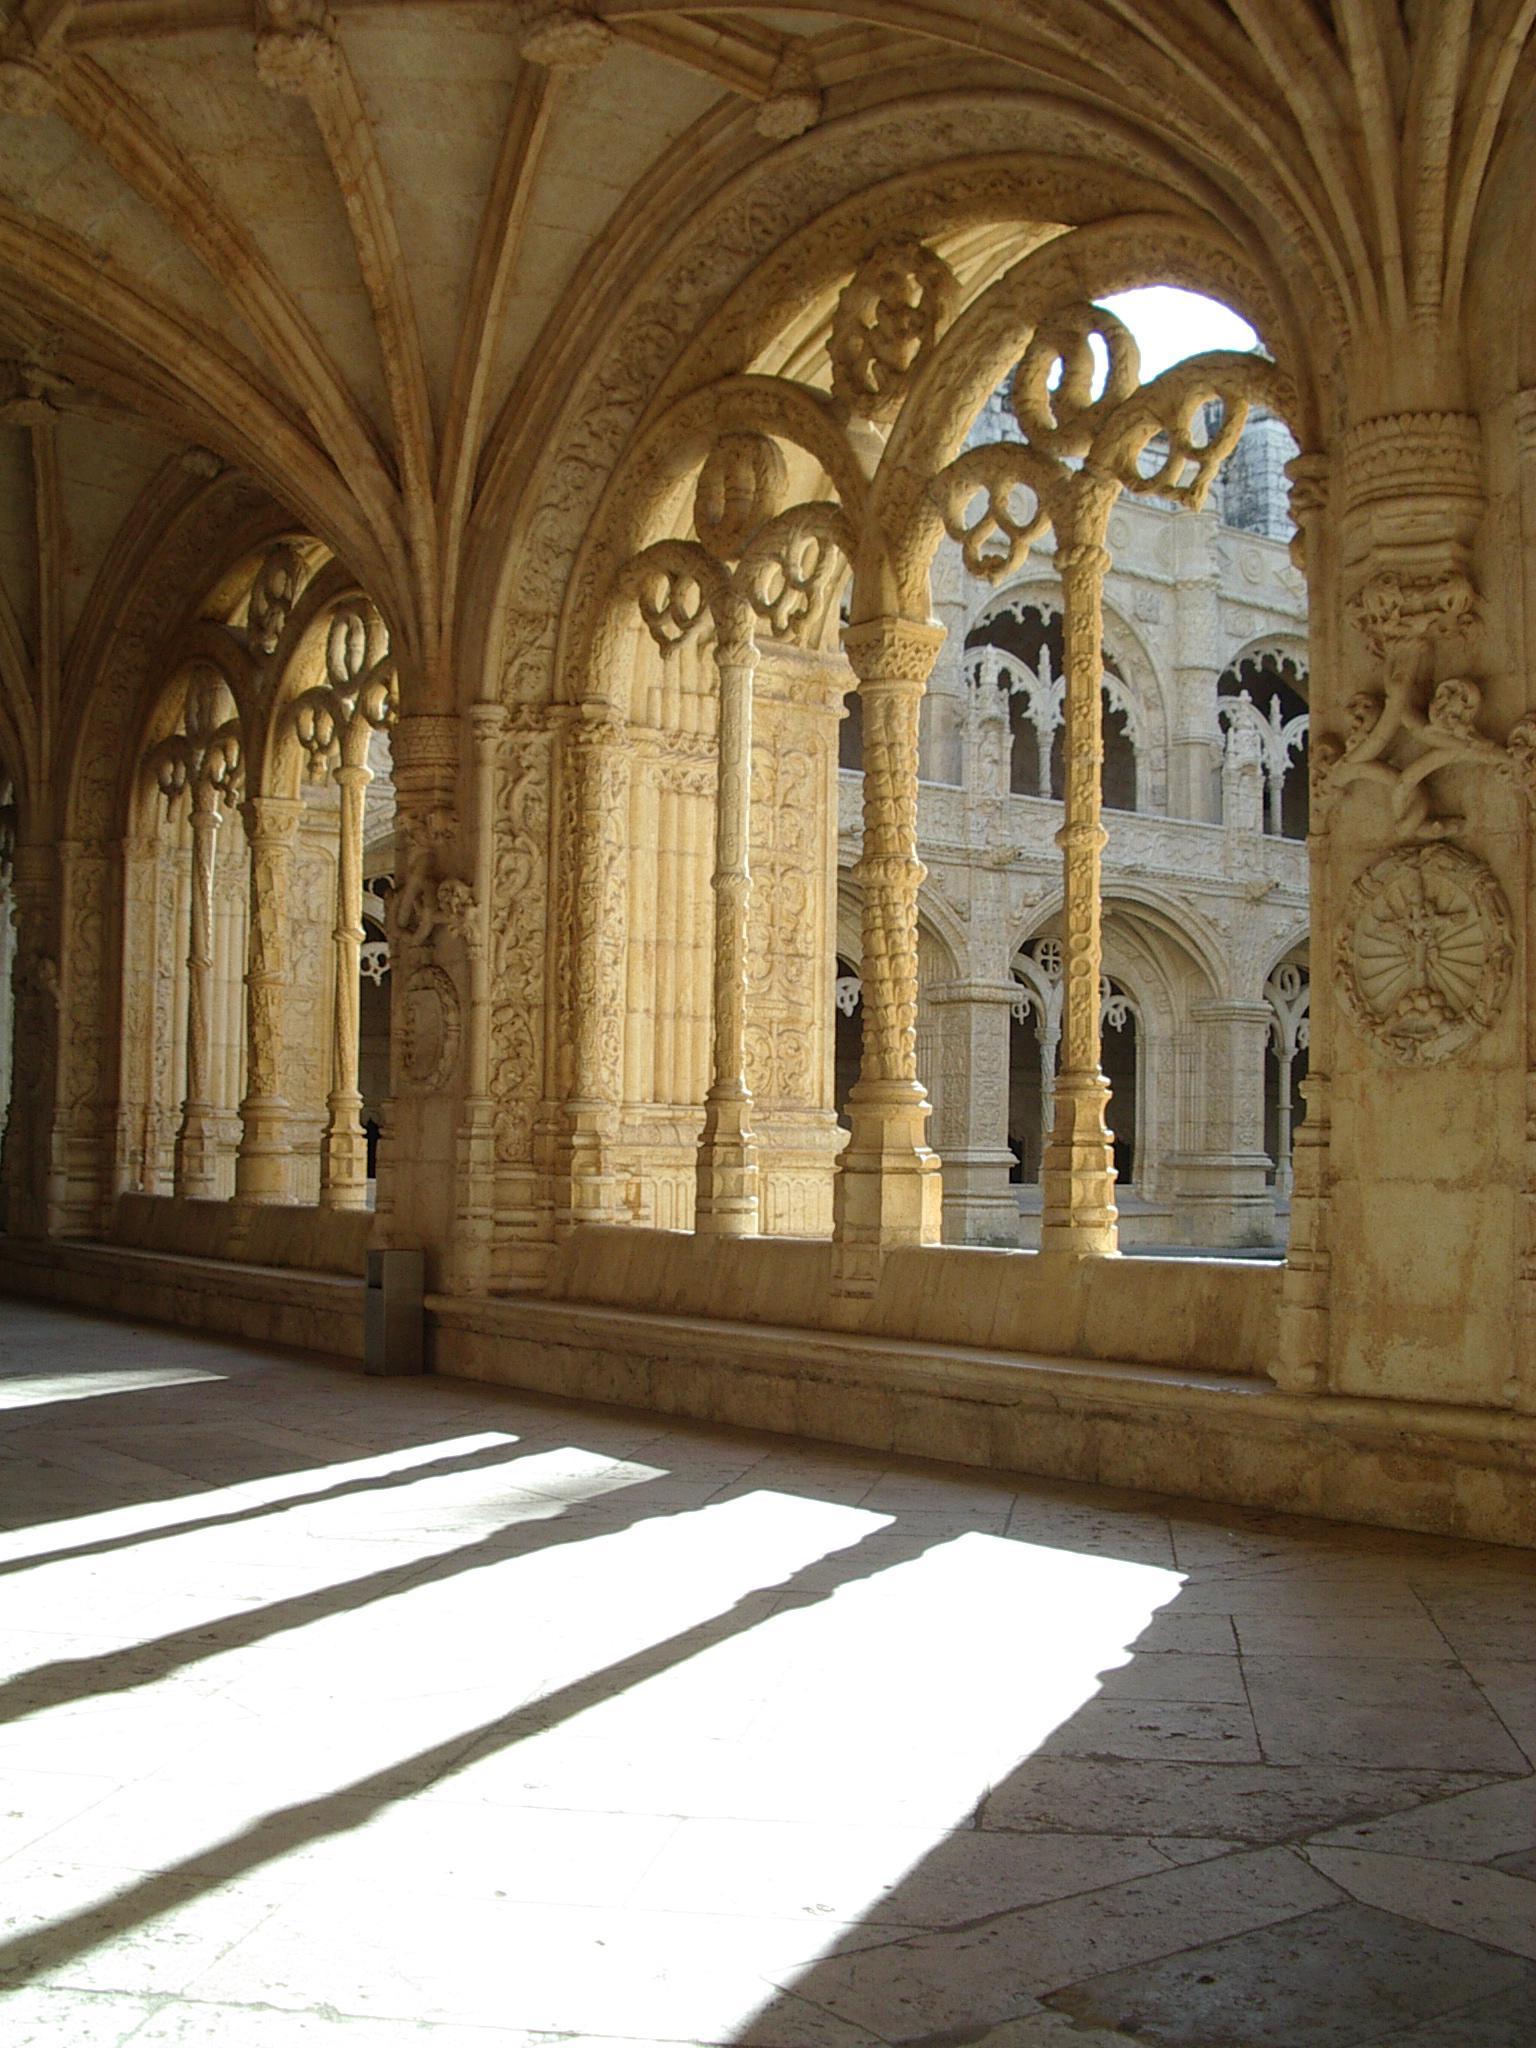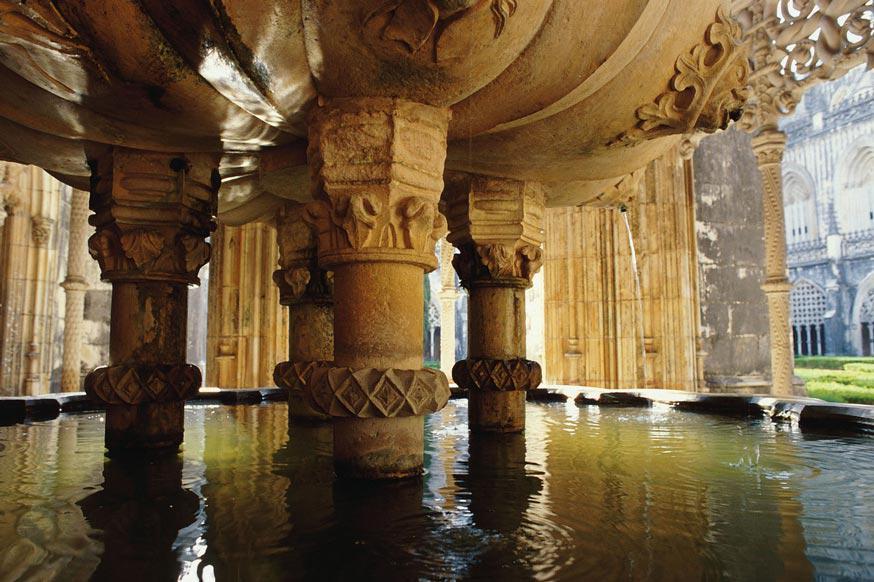The first image is the image on the left, the second image is the image on the right. Given the left and right images, does the statement "A single door can be seen at the end of the corridor in one of the images." hold true? Answer yes or no. No. 